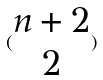<formula> <loc_0><loc_0><loc_500><loc_500>( \begin{matrix} n + 2 \\ 2 \end{matrix} )</formula> 